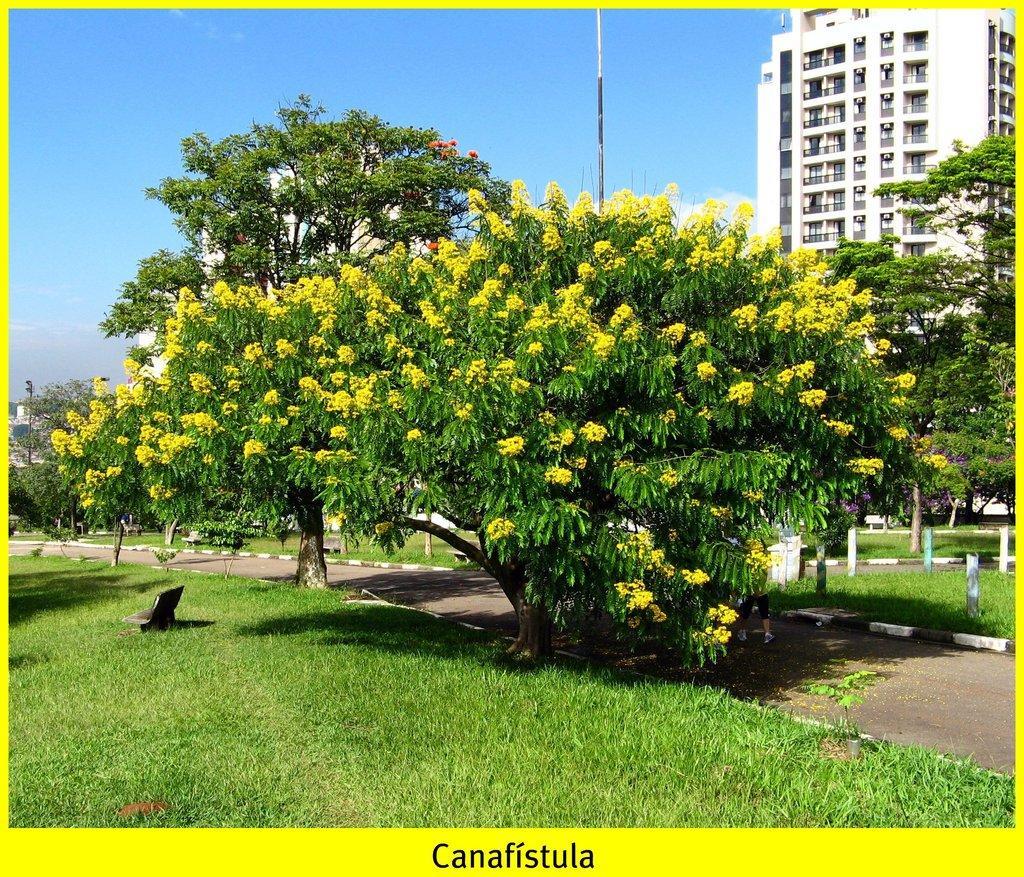Could you give a brief overview of what you see in this image? In this image we can see a tree with flowers and there is an object on the grass on the ground. In the background we can see road, trees, poles, buildings and clouds in the sky. 